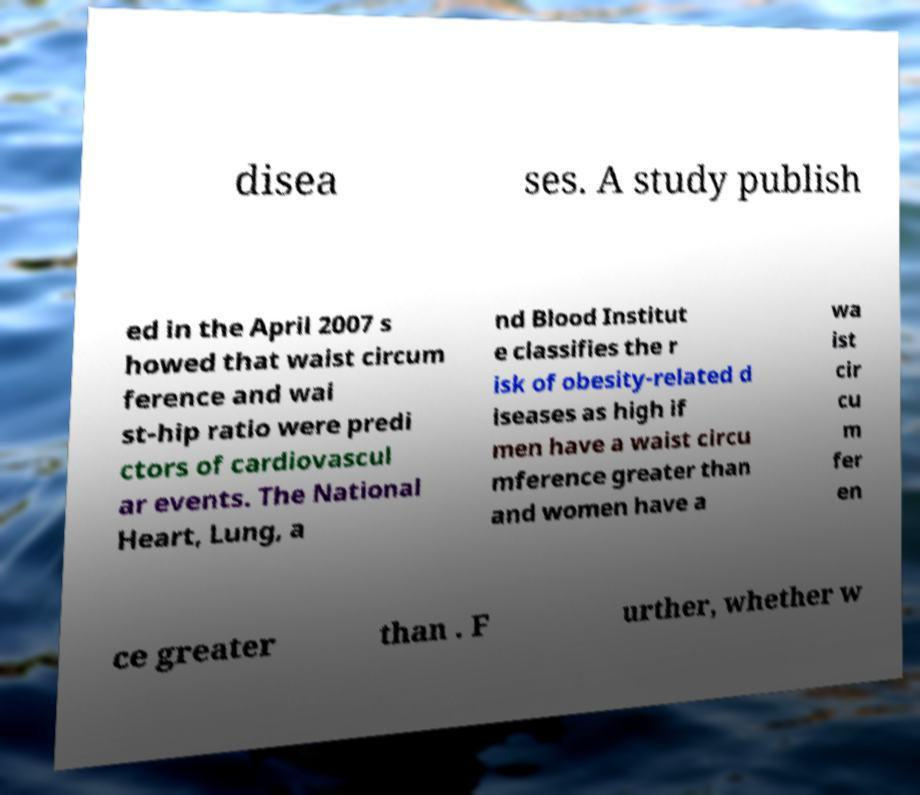Could you assist in decoding the text presented in this image and type it out clearly? disea ses. A study publish ed in the April 2007 s howed that waist circum ference and wai st-hip ratio were predi ctors of cardiovascul ar events. The National Heart, Lung, a nd Blood Institut e classifies the r isk of obesity-related d iseases as high if men have a waist circu mference greater than and women have a wa ist cir cu m fer en ce greater than . F urther, whether w 